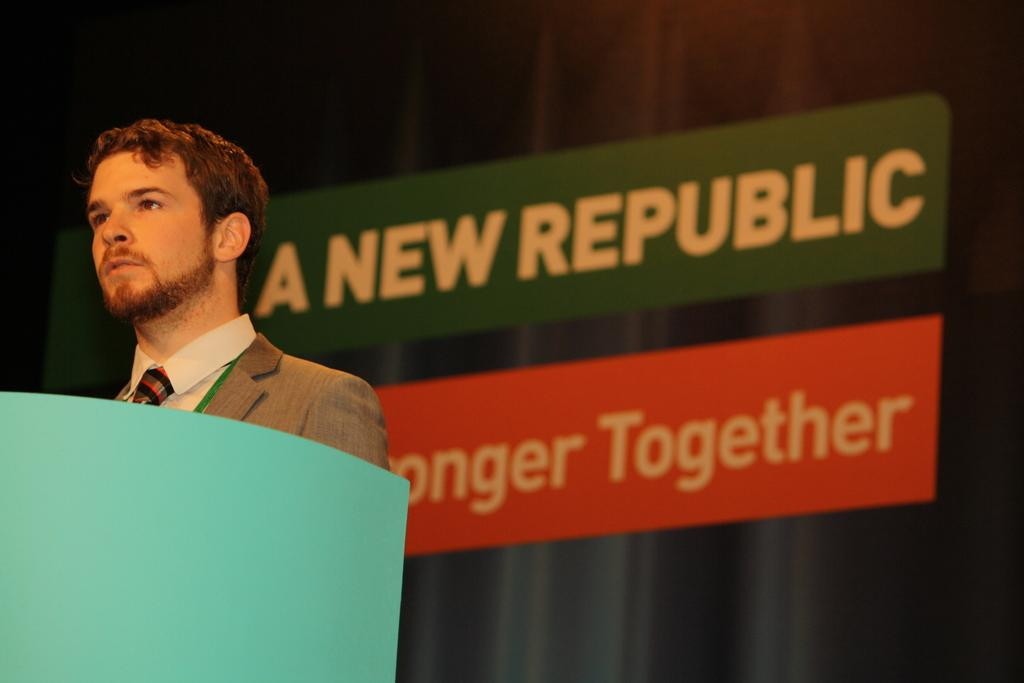Who is present in the image? There is a man in the image. What is in front of the man? There is a green object in front of the man. What can be seen in the background of the image? There are boards visible in the background of the image. What type of yam is being used to paint the boards in the image? There is no yam or painting activity present in the image. 